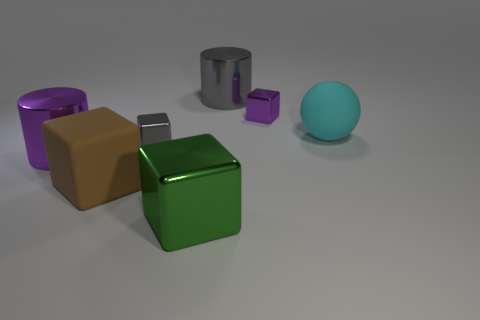Could you suggest what kind of material each object might be made of? Based on their appearance, the objects could be made from different materials. The large gray cylinder and the cubes (brown, green, and small purple) seem to have a matte finish, suggesting a material like plastic or painted wood. The silver cube has reflective properties consistent with a metallic surface, and the purple cylinder's slight sheen might indicate a metallic or plastic composite. The teal sphere has a smooth finish that could be indicative of a polished stone or coated metal. 